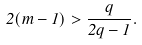Convert formula to latex. <formula><loc_0><loc_0><loc_500><loc_500>2 ( m - 1 ) > \frac { q } { 2 q - 1 } .</formula> 